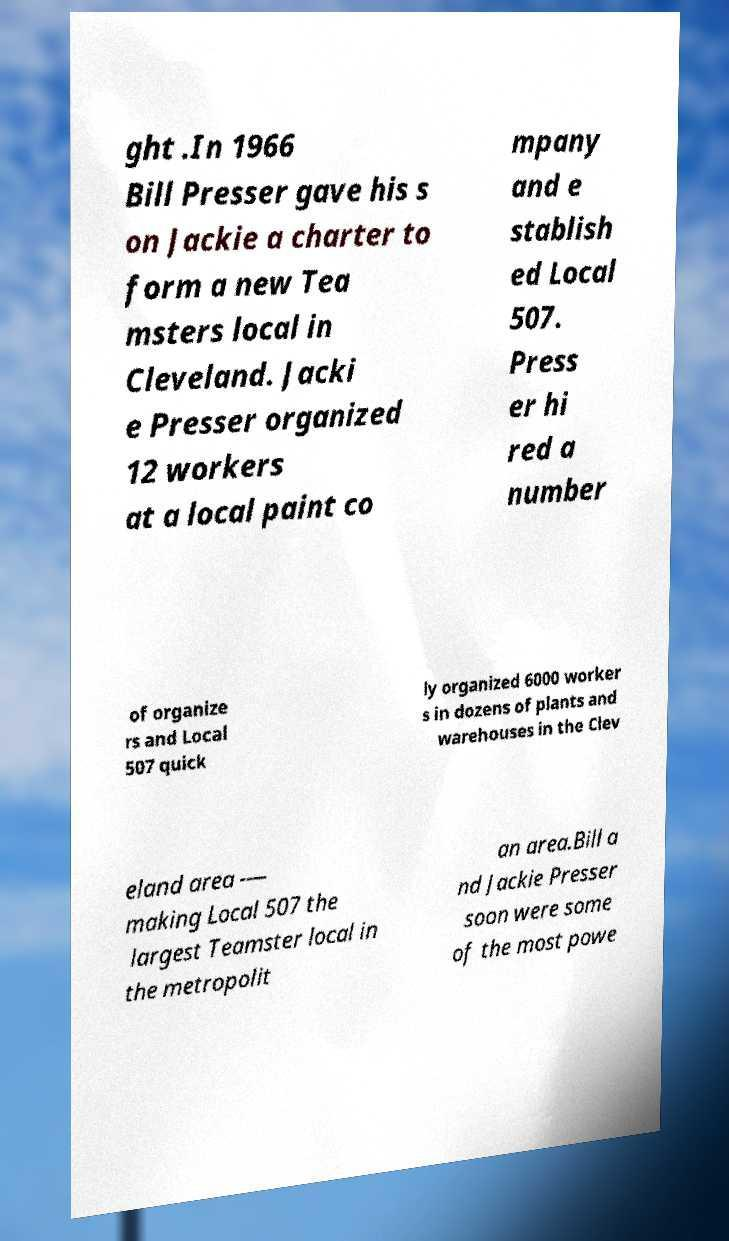Please read and relay the text visible in this image. What does it say? ght .In 1966 Bill Presser gave his s on Jackie a charter to form a new Tea msters local in Cleveland. Jacki e Presser organized 12 workers at a local paint co mpany and e stablish ed Local 507. Press er hi red a number of organize rs and Local 507 quick ly organized 6000 worker s in dozens of plants and warehouses in the Clev eland area -— making Local 507 the largest Teamster local in the metropolit an area.Bill a nd Jackie Presser soon were some of the most powe 